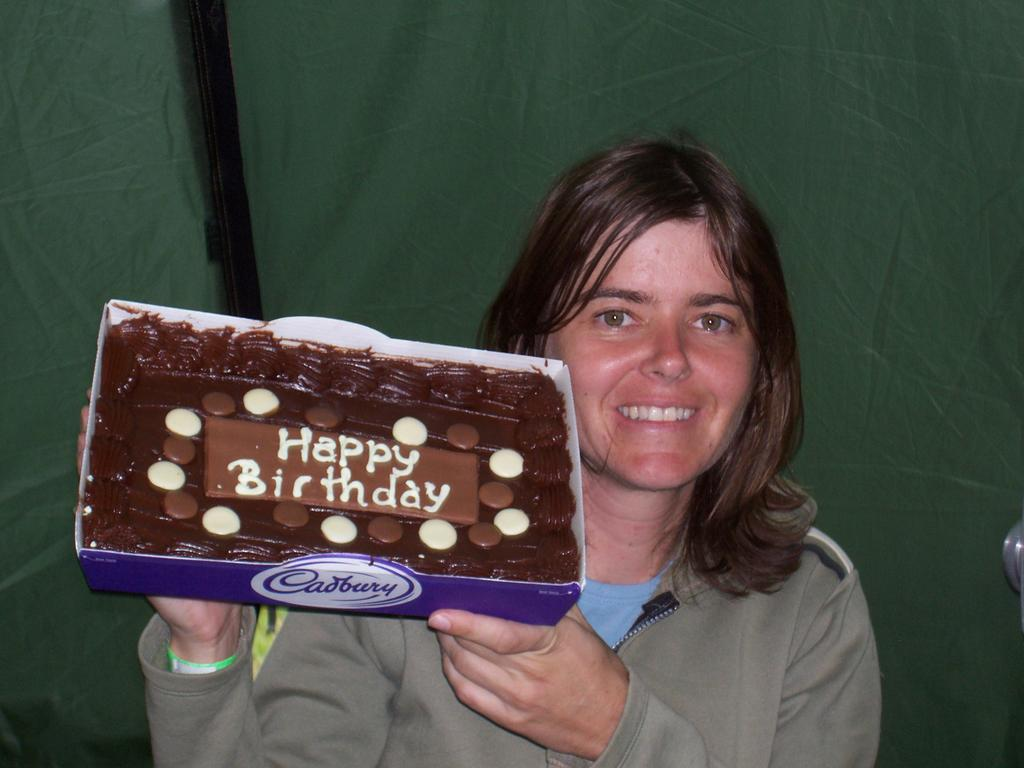Who is present in the image? There is a woman in the image. What is the woman doing in the image? The woman is smiling in the image. What is the woman holding in her hands? The woman is holding a chocolate pack in her hands. What color cloth can be seen in the background of the image? There is a green color cloth in the background of the image. What type of income does the woman earn from her job in the image? There is no information about the woman's job or income in the image. 